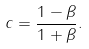<formula> <loc_0><loc_0><loc_500><loc_500>c = \frac { 1 - \beta } { 1 + \beta } .</formula> 